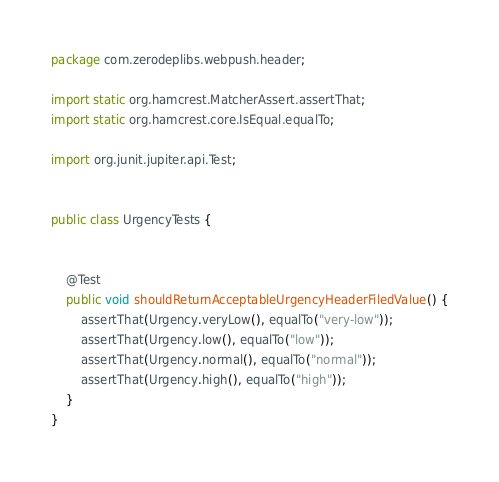Convert code to text. <code><loc_0><loc_0><loc_500><loc_500><_Java_>package com.zerodeplibs.webpush.header;

import static org.hamcrest.MatcherAssert.assertThat;
import static org.hamcrest.core.IsEqual.equalTo;

import org.junit.jupiter.api.Test;


public class UrgencyTests {


    @Test
    public void shouldReturnAcceptableUrgencyHeaderFiledValue() {
        assertThat(Urgency.veryLow(), equalTo("very-low"));
        assertThat(Urgency.low(), equalTo("low"));
        assertThat(Urgency.normal(), equalTo("normal"));
        assertThat(Urgency.high(), equalTo("high"));
    }
}
</code> 